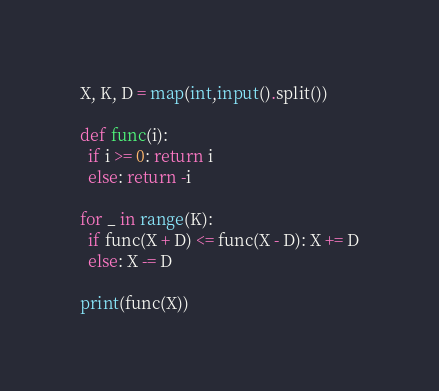Convert code to text. <code><loc_0><loc_0><loc_500><loc_500><_Python_>X, K, D = map(int,input().split())

def func(i):
  if i >= 0: return i
  else: return -i

for _ in range(K):
  if func(X + D) <= func(X - D): X += D
  else: X -= D

print(func(X))</code> 